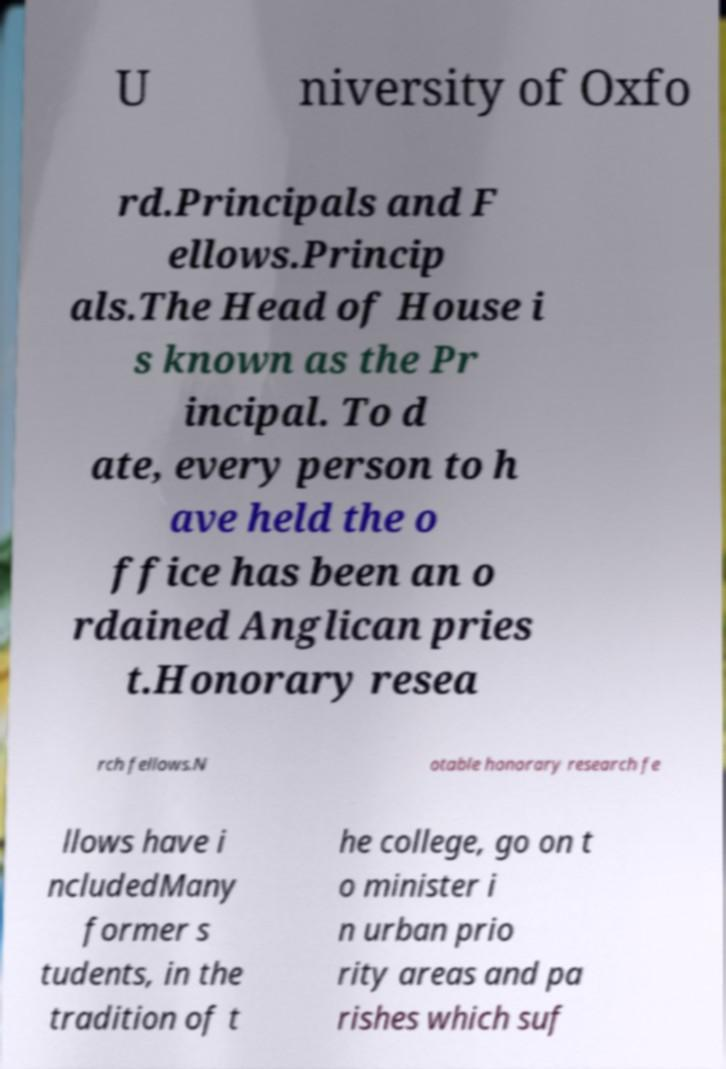Can you accurately transcribe the text from the provided image for me? U niversity of Oxfo rd.Principals and F ellows.Princip als.The Head of House i s known as the Pr incipal. To d ate, every person to h ave held the o ffice has been an o rdained Anglican pries t.Honorary resea rch fellows.N otable honorary research fe llows have i ncludedMany former s tudents, in the tradition of t he college, go on t o minister i n urban prio rity areas and pa rishes which suf 